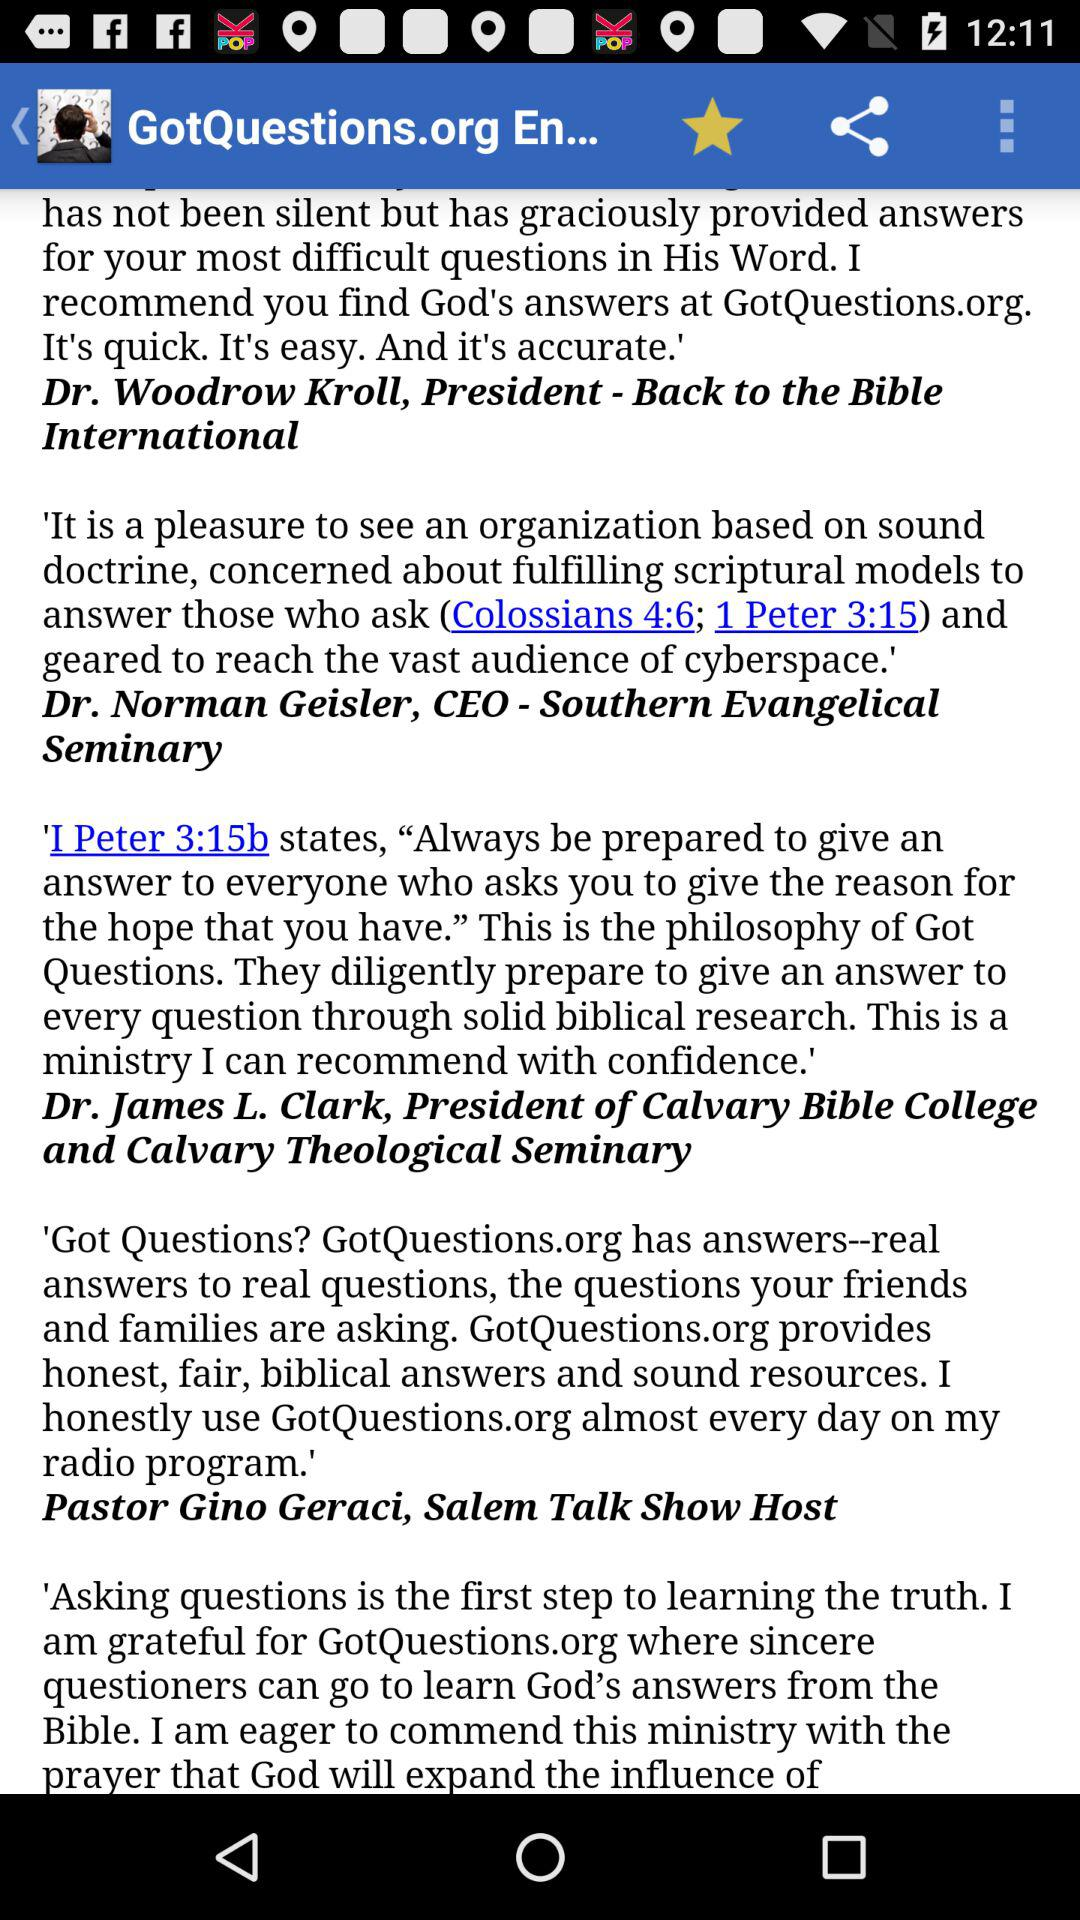Who is the president of Back to the Bible International? The president of Back to the Bible International is Dr. Woodrow Kroll. 